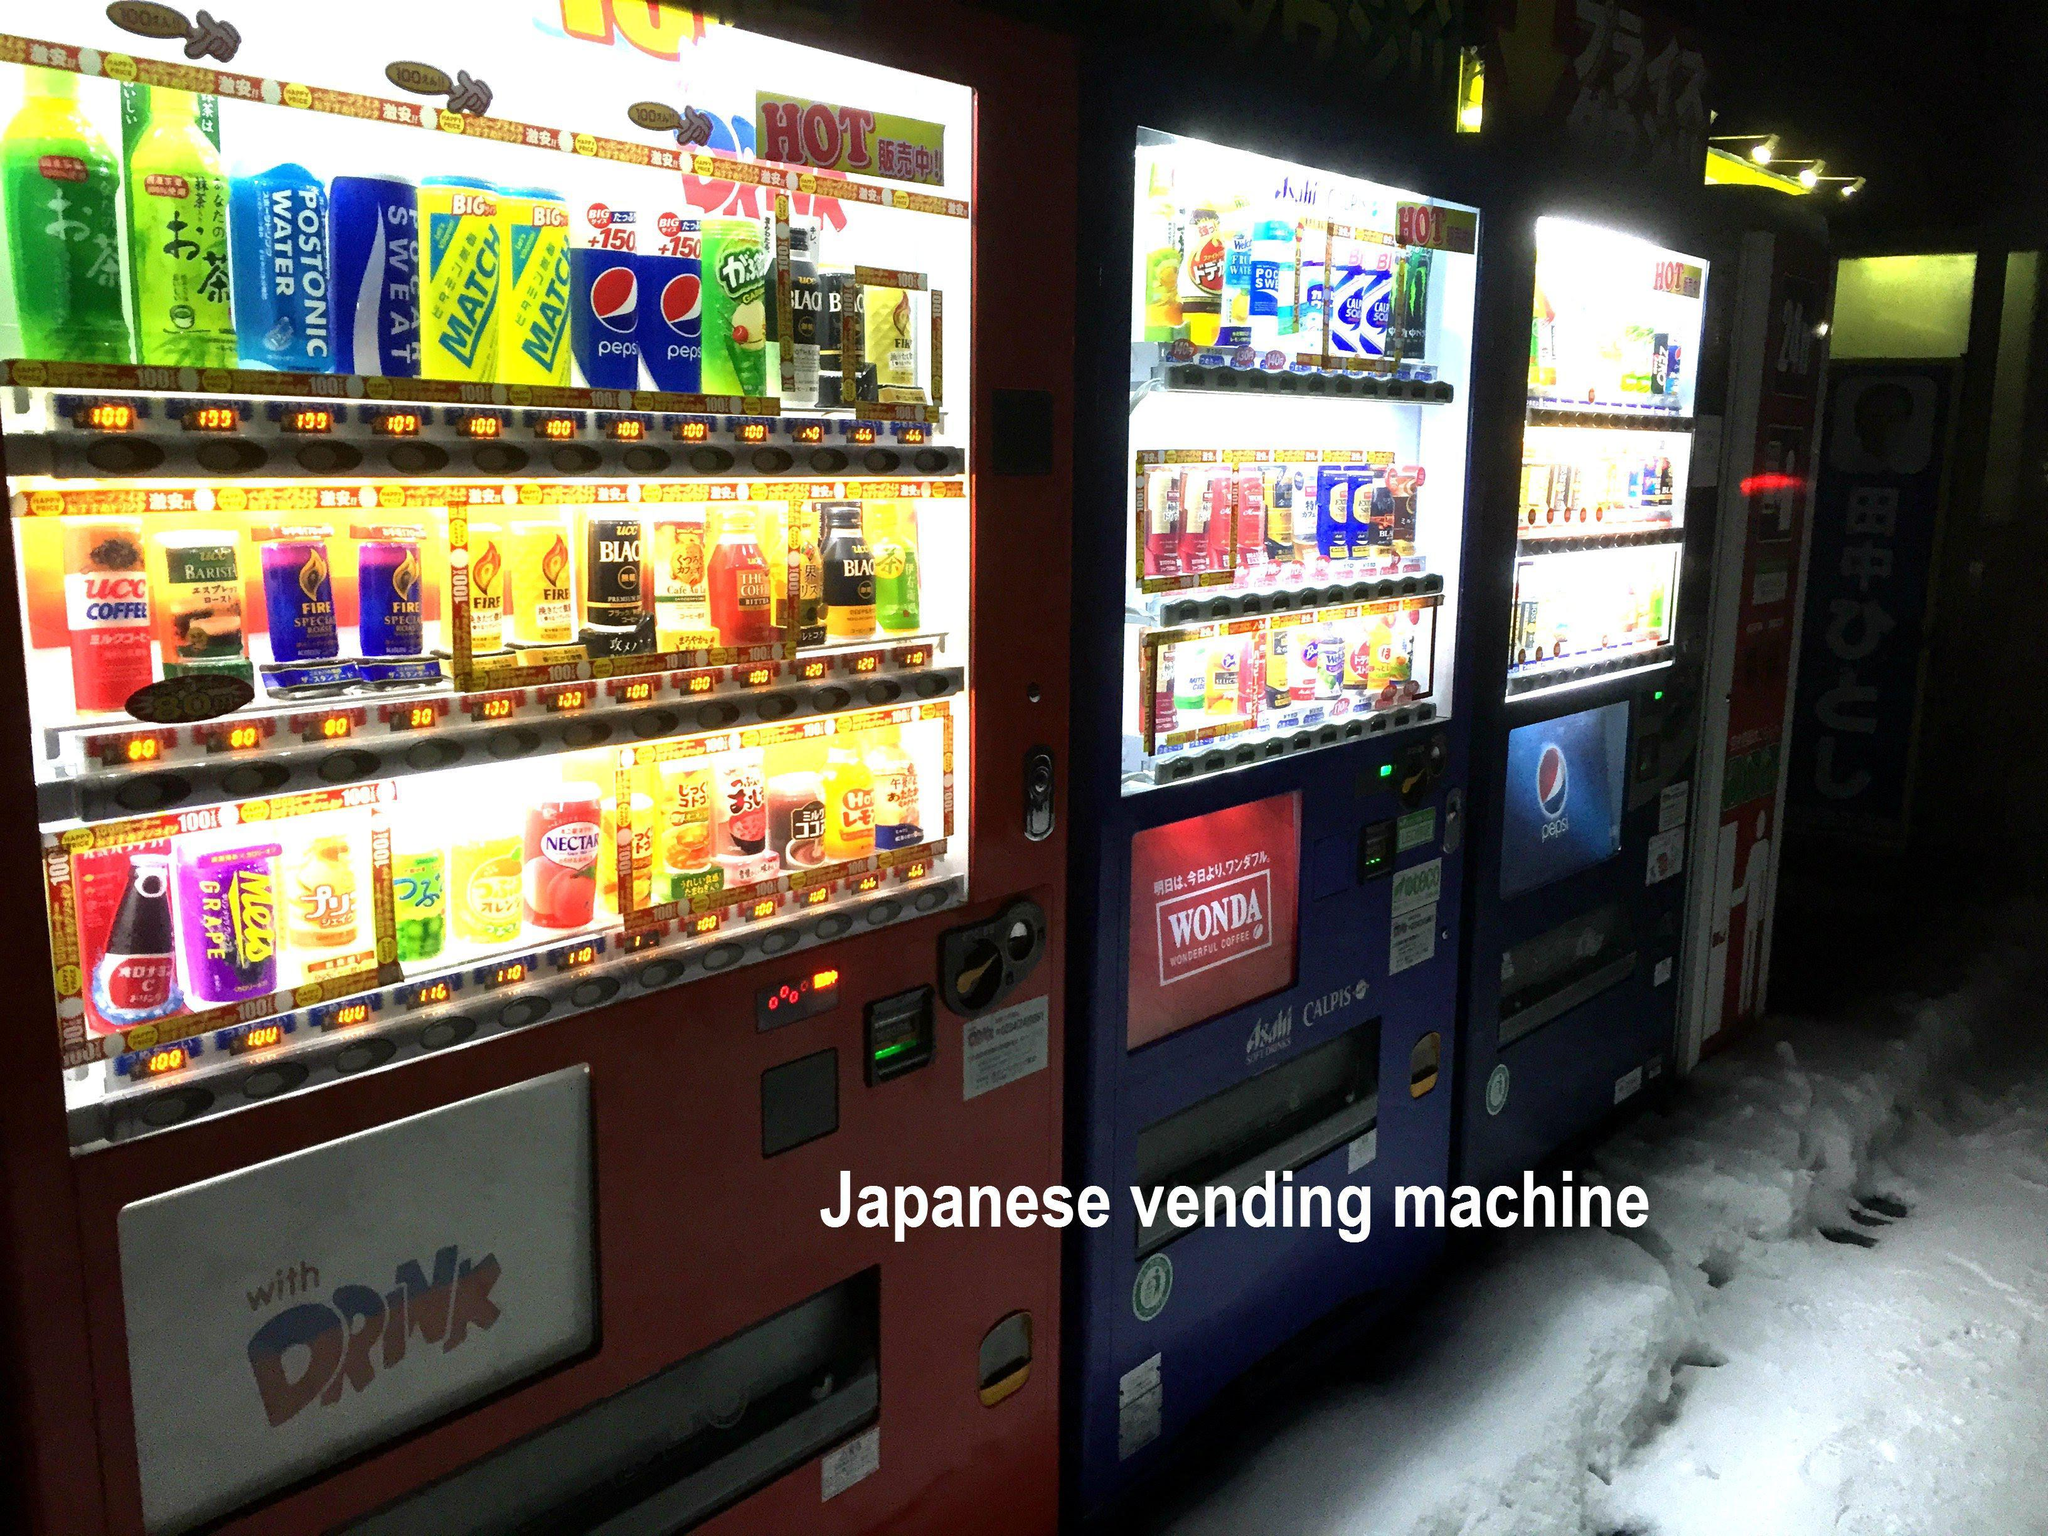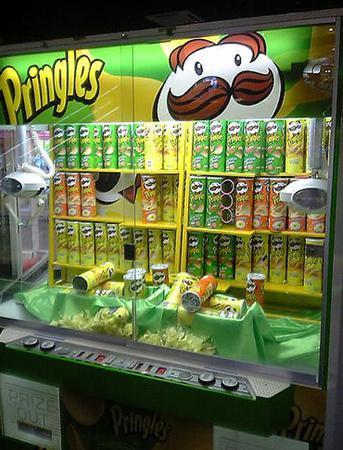The first image is the image on the left, the second image is the image on the right. Given the left and right images, does the statement "At least one of the machines is bright red." hold true? Answer yes or no. No. 